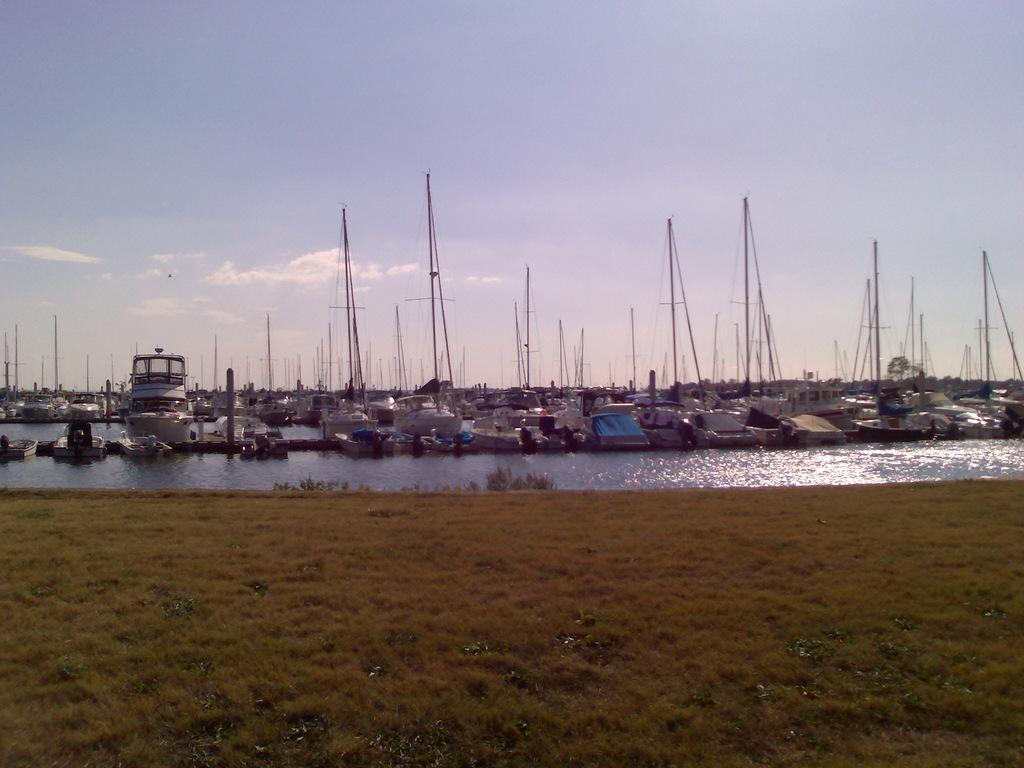In one or two sentences, can you explain what this image depicts? In this image there are few boats and ships on the river, in the foreground of the image there is the surface of the grass. In the background there is the sky. 